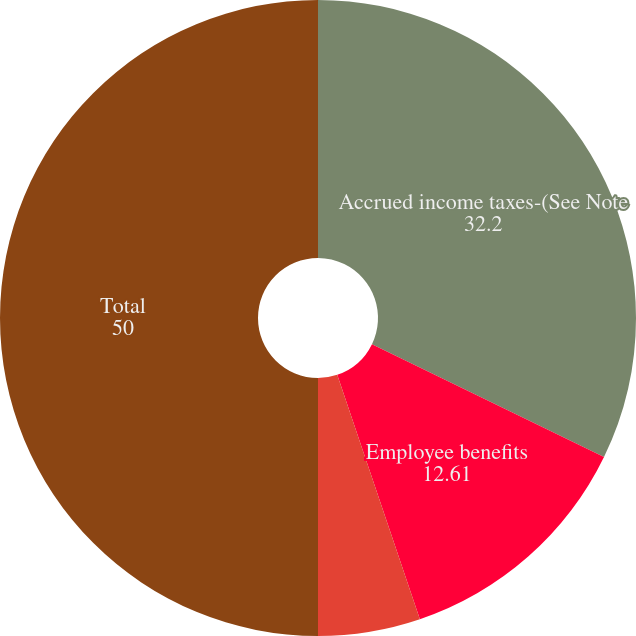Convert chart to OTSL. <chart><loc_0><loc_0><loc_500><loc_500><pie_chart><fcel>Accrued income taxes-(See Note<fcel>Employee benefits<fcel>Other<fcel>Total<nl><fcel>32.2%<fcel>12.61%<fcel>5.19%<fcel>50.0%<nl></chart> 